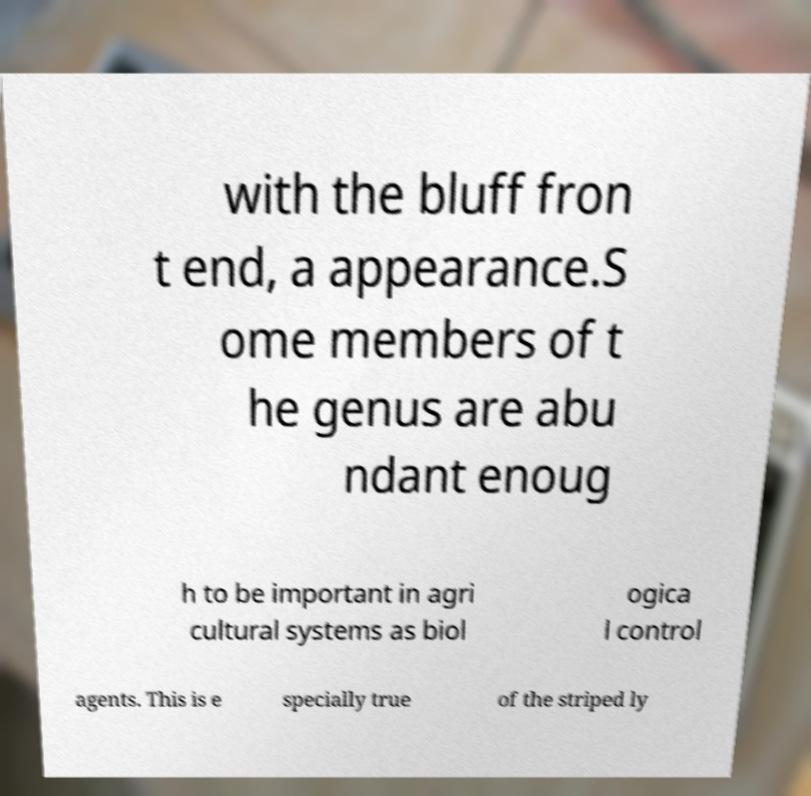For documentation purposes, I need the text within this image transcribed. Could you provide that? with the bluff fron t end, a appearance.S ome members of t he genus are abu ndant enoug h to be important in agri cultural systems as biol ogica l control agents. This is e specially true of the striped ly 